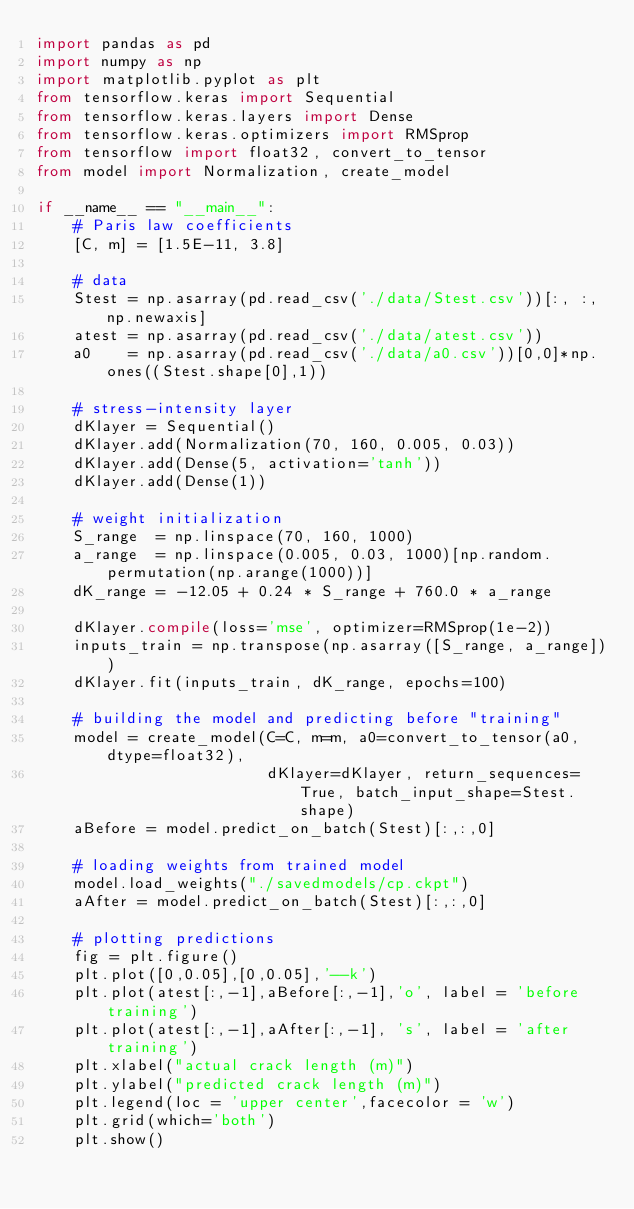<code> <loc_0><loc_0><loc_500><loc_500><_Python_>import pandas as pd
import numpy as np
import matplotlib.pyplot as plt
from tensorflow.keras import Sequential
from tensorflow.keras.layers import Dense
from tensorflow.keras.optimizers import RMSprop
from tensorflow import float32, convert_to_tensor
from model import Normalization, create_model

if __name__ == "__main__":
    # Paris law coefficients
    [C, m] = [1.5E-11, 3.8]
    
    # data
    Stest = np.asarray(pd.read_csv('./data/Stest.csv'))[:, :, np.newaxis]
    atest = np.asarray(pd.read_csv('./data/atest.csv'))
    a0    = np.asarray(pd.read_csv('./data/a0.csv'))[0,0]*np.ones((Stest.shape[0],1))
    
    # stress-intensity layer
    dKlayer = Sequential()
    dKlayer.add(Normalization(70, 160, 0.005, 0.03))
    dKlayer.add(Dense(5, activation='tanh'))
    dKlayer.add(Dense(1))

    # weight initialization
    S_range  = np.linspace(70, 160, 1000)
    a_range  = np.linspace(0.005, 0.03, 1000)[np.random.permutation(np.arange(1000))]
    dK_range = -12.05 + 0.24 * S_range + 760.0 * a_range

    dKlayer.compile(loss='mse', optimizer=RMSprop(1e-2))
    inputs_train = np.transpose(np.asarray([S_range, a_range]))
    dKlayer.fit(inputs_train, dK_range, epochs=100)

    # building the model and predicting before "training"
    model = create_model(C=C, m=m, a0=convert_to_tensor(a0, dtype=float32),
                         dKlayer=dKlayer, return_sequences=True, batch_input_shape=Stest.shape)
    aBefore = model.predict_on_batch(Stest)[:,:,0]
    
    # loading weights from trained model
    model.load_weights("./savedmodels/cp.ckpt")
    aAfter = model.predict_on_batch(Stest)[:,:,0]
    
    # plotting predictions
    fig = plt.figure()
    plt.plot([0,0.05],[0,0.05],'--k')
    plt.plot(atest[:,-1],aBefore[:,-1],'o', label = 'before training')
    plt.plot(atest[:,-1],aAfter[:,-1], 's', label = 'after training')
    plt.xlabel("actual crack length (m)")
    plt.ylabel("predicted crack length (m)")
    plt.legend(loc = 'upper center',facecolor = 'w')
    plt.grid(which='both')
    plt.show()
</code> 